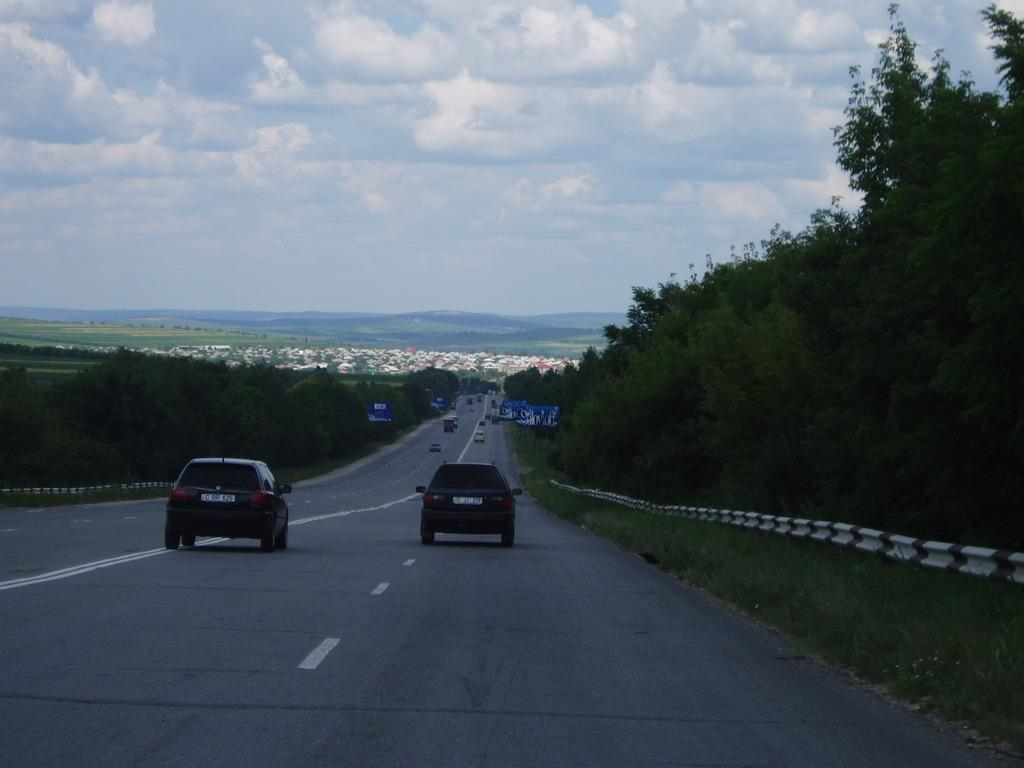What is the main feature of the image? There is a road in the image. What can be seen on the road? There are vehicles on the road. What type of vegetation is present alongside the road? There are trees on both sides of the road. What safety feature is visible in the image? The railing is visible in the image. What structures can be seen in the distance? There are buildings in the background of the image. What part of the natural environment is visible in the image? The sky is visible in the background of the image. What type of notebook is being used by the protesters in the image? There are no protesters or notebooks present in the image. What type of stitch is being used to repair the road in the image? There is no repair work or stitching visible in the image; it features a road with vehicles and trees. 